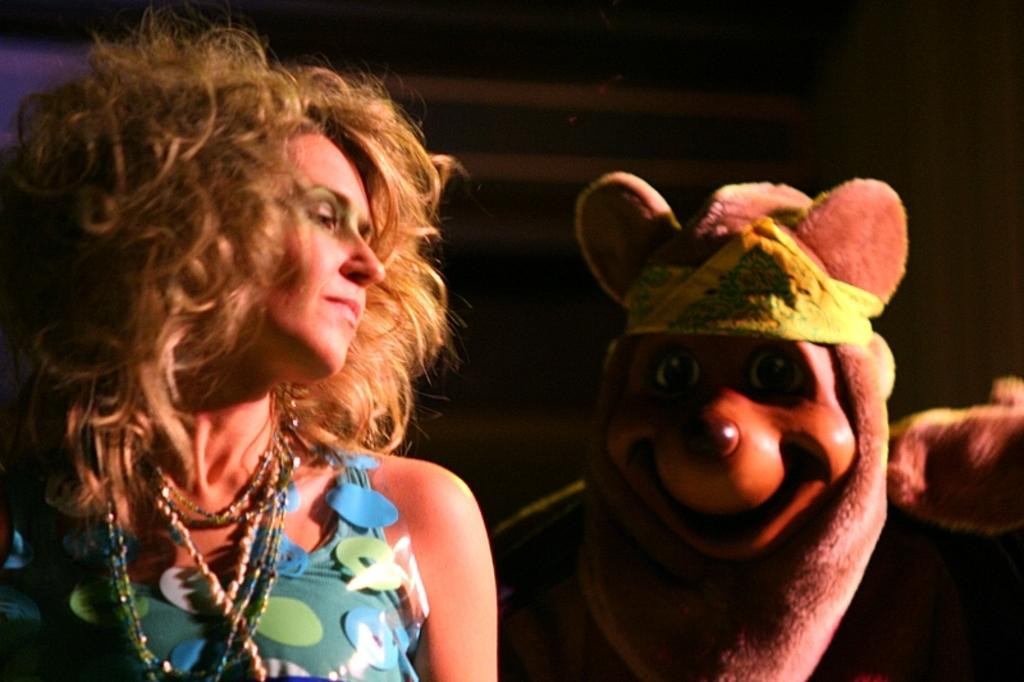What is the main subject in the foreground of the picture? There is a woman in the foreground of the picture. What is the woman wearing? The woman is wearing a blue dress. Can you describe another person in the image? There is a person wearing a mask in the image. How is the mask positioned on the person? The mask is on the person's head. What type of background can be seen in the image? There is a wall and a curtain in the image. What is the measurement of the earth in the image? There is no reference to the earth or any measurements in the image. 